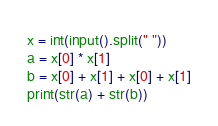<code> <loc_0><loc_0><loc_500><loc_500><_Python_>x = int(input().split(" "))
a = x[0] * x[1]
b = x[0] + x[1] + x[0] + x[1]
print(str(a) + str(b))
</code> 